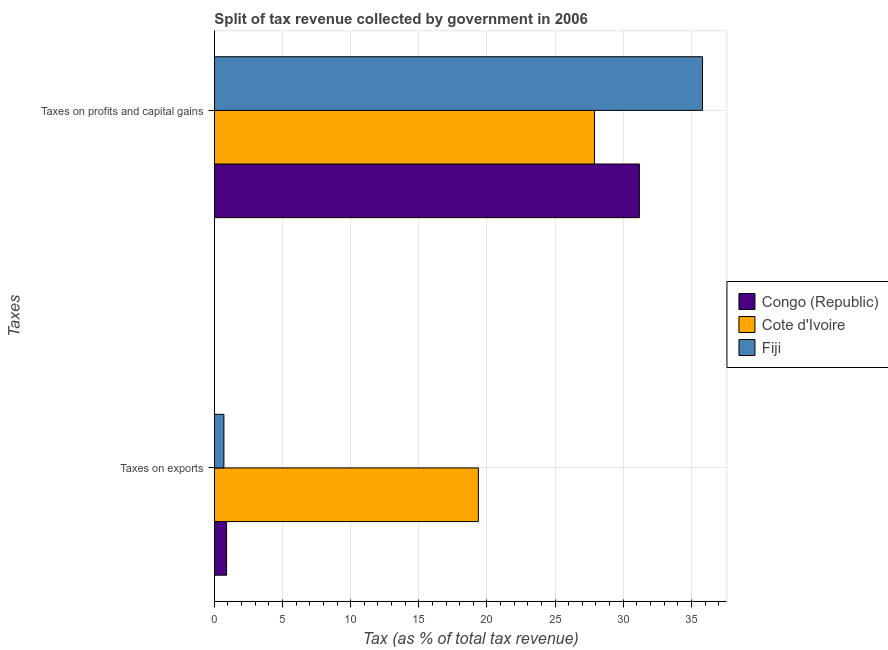How many different coloured bars are there?
Make the answer very short. 3. Are the number of bars per tick equal to the number of legend labels?
Your answer should be compact. Yes. How many bars are there on the 2nd tick from the bottom?
Offer a very short reply. 3. What is the label of the 1st group of bars from the top?
Offer a very short reply. Taxes on profits and capital gains. What is the percentage of revenue obtained from taxes on profits and capital gains in Fiji?
Keep it short and to the point. 35.82. Across all countries, what is the maximum percentage of revenue obtained from taxes on profits and capital gains?
Provide a short and direct response. 35.82. Across all countries, what is the minimum percentage of revenue obtained from taxes on profits and capital gains?
Give a very brief answer. 27.89. In which country was the percentage of revenue obtained from taxes on exports maximum?
Your answer should be compact. Cote d'Ivoire. In which country was the percentage of revenue obtained from taxes on profits and capital gains minimum?
Ensure brevity in your answer.  Cote d'Ivoire. What is the total percentage of revenue obtained from taxes on profits and capital gains in the graph?
Ensure brevity in your answer.  94.89. What is the difference between the percentage of revenue obtained from taxes on profits and capital gains in Cote d'Ivoire and that in Fiji?
Give a very brief answer. -7.92. What is the difference between the percentage of revenue obtained from taxes on profits and capital gains in Congo (Republic) and the percentage of revenue obtained from taxes on exports in Cote d'Ivoire?
Offer a very short reply. 11.81. What is the average percentage of revenue obtained from taxes on exports per country?
Offer a very short reply. 6.99. What is the difference between the percentage of revenue obtained from taxes on profits and capital gains and percentage of revenue obtained from taxes on exports in Cote d'Ivoire?
Keep it short and to the point. 8.52. What is the ratio of the percentage of revenue obtained from taxes on profits and capital gains in Congo (Republic) to that in Cote d'Ivoire?
Ensure brevity in your answer.  1.12. What does the 1st bar from the top in Taxes on profits and capital gains represents?
Provide a short and direct response. Fiji. What does the 2nd bar from the bottom in Taxes on exports represents?
Provide a short and direct response. Cote d'Ivoire. How many bars are there?
Offer a terse response. 6. Are all the bars in the graph horizontal?
Make the answer very short. Yes. What is the difference between two consecutive major ticks on the X-axis?
Keep it short and to the point. 5. Are the values on the major ticks of X-axis written in scientific E-notation?
Make the answer very short. No. Where does the legend appear in the graph?
Provide a succinct answer. Center right. How many legend labels are there?
Your response must be concise. 3. How are the legend labels stacked?
Make the answer very short. Vertical. What is the title of the graph?
Provide a succinct answer. Split of tax revenue collected by government in 2006. What is the label or title of the X-axis?
Your answer should be compact. Tax (as % of total tax revenue). What is the label or title of the Y-axis?
Give a very brief answer. Taxes. What is the Tax (as % of total tax revenue) of Congo (Republic) in Taxes on exports?
Ensure brevity in your answer.  0.9. What is the Tax (as % of total tax revenue) of Cote d'Ivoire in Taxes on exports?
Give a very brief answer. 19.37. What is the Tax (as % of total tax revenue) in Fiji in Taxes on exports?
Offer a very short reply. 0.7. What is the Tax (as % of total tax revenue) of Congo (Republic) in Taxes on profits and capital gains?
Give a very brief answer. 31.18. What is the Tax (as % of total tax revenue) of Cote d'Ivoire in Taxes on profits and capital gains?
Provide a succinct answer. 27.89. What is the Tax (as % of total tax revenue) in Fiji in Taxes on profits and capital gains?
Your response must be concise. 35.82. Across all Taxes, what is the maximum Tax (as % of total tax revenue) in Congo (Republic)?
Offer a terse response. 31.18. Across all Taxes, what is the maximum Tax (as % of total tax revenue) of Cote d'Ivoire?
Keep it short and to the point. 27.89. Across all Taxes, what is the maximum Tax (as % of total tax revenue) of Fiji?
Your response must be concise. 35.82. Across all Taxes, what is the minimum Tax (as % of total tax revenue) of Congo (Republic)?
Ensure brevity in your answer.  0.9. Across all Taxes, what is the minimum Tax (as % of total tax revenue) of Cote d'Ivoire?
Give a very brief answer. 19.37. Across all Taxes, what is the minimum Tax (as % of total tax revenue) in Fiji?
Ensure brevity in your answer.  0.7. What is the total Tax (as % of total tax revenue) in Congo (Republic) in the graph?
Give a very brief answer. 32.08. What is the total Tax (as % of total tax revenue) in Cote d'Ivoire in the graph?
Keep it short and to the point. 47.26. What is the total Tax (as % of total tax revenue) in Fiji in the graph?
Offer a terse response. 36.52. What is the difference between the Tax (as % of total tax revenue) of Congo (Republic) in Taxes on exports and that in Taxes on profits and capital gains?
Give a very brief answer. -30.29. What is the difference between the Tax (as % of total tax revenue) of Cote d'Ivoire in Taxes on exports and that in Taxes on profits and capital gains?
Keep it short and to the point. -8.52. What is the difference between the Tax (as % of total tax revenue) in Fiji in Taxes on exports and that in Taxes on profits and capital gains?
Offer a very short reply. -35.12. What is the difference between the Tax (as % of total tax revenue) in Congo (Republic) in Taxes on exports and the Tax (as % of total tax revenue) in Cote d'Ivoire in Taxes on profits and capital gains?
Provide a succinct answer. -26.99. What is the difference between the Tax (as % of total tax revenue) of Congo (Republic) in Taxes on exports and the Tax (as % of total tax revenue) of Fiji in Taxes on profits and capital gains?
Offer a very short reply. -34.92. What is the difference between the Tax (as % of total tax revenue) of Cote d'Ivoire in Taxes on exports and the Tax (as % of total tax revenue) of Fiji in Taxes on profits and capital gains?
Offer a terse response. -16.44. What is the average Tax (as % of total tax revenue) in Congo (Republic) per Taxes?
Provide a short and direct response. 16.04. What is the average Tax (as % of total tax revenue) in Cote d'Ivoire per Taxes?
Offer a very short reply. 23.63. What is the average Tax (as % of total tax revenue) of Fiji per Taxes?
Make the answer very short. 18.26. What is the difference between the Tax (as % of total tax revenue) of Congo (Republic) and Tax (as % of total tax revenue) of Cote d'Ivoire in Taxes on exports?
Provide a succinct answer. -18.48. What is the difference between the Tax (as % of total tax revenue) of Congo (Republic) and Tax (as % of total tax revenue) of Fiji in Taxes on exports?
Keep it short and to the point. 0.2. What is the difference between the Tax (as % of total tax revenue) of Cote d'Ivoire and Tax (as % of total tax revenue) of Fiji in Taxes on exports?
Keep it short and to the point. 18.67. What is the difference between the Tax (as % of total tax revenue) in Congo (Republic) and Tax (as % of total tax revenue) in Cote d'Ivoire in Taxes on profits and capital gains?
Ensure brevity in your answer.  3.29. What is the difference between the Tax (as % of total tax revenue) in Congo (Republic) and Tax (as % of total tax revenue) in Fiji in Taxes on profits and capital gains?
Offer a very short reply. -4.63. What is the difference between the Tax (as % of total tax revenue) of Cote d'Ivoire and Tax (as % of total tax revenue) of Fiji in Taxes on profits and capital gains?
Ensure brevity in your answer.  -7.92. What is the ratio of the Tax (as % of total tax revenue) of Congo (Republic) in Taxes on exports to that in Taxes on profits and capital gains?
Your answer should be very brief. 0.03. What is the ratio of the Tax (as % of total tax revenue) in Cote d'Ivoire in Taxes on exports to that in Taxes on profits and capital gains?
Your answer should be compact. 0.69. What is the ratio of the Tax (as % of total tax revenue) in Fiji in Taxes on exports to that in Taxes on profits and capital gains?
Offer a terse response. 0.02. What is the difference between the highest and the second highest Tax (as % of total tax revenue) in Congo (Republic)?
Keep it short and to the point. 30.29. What is the difference between the highest and the second highest Tax (as % of total tax revenue) of Cote d'Ivoire?
Offer a terse response. 8.52. What is the difference between the highest and the second highest Tax (as % of total tax revenue) of Fiji?
Provide a short and direct response. 35.12. What is the difference between the highest and the lowest Tax (as % of total tax revenue) in Congo (Republic)?
Provide a short and direct response. 30.29. What is the difference between the highest and the lowest Tax (as % of total tax revenue) in Cote d'Ivoire?
Keep it short and to the point. 8.52. What is the difference between the highest and the lowest Tax (as % of total tax revenue) of Fiji?
Provide a succinct answer. 35.12. 